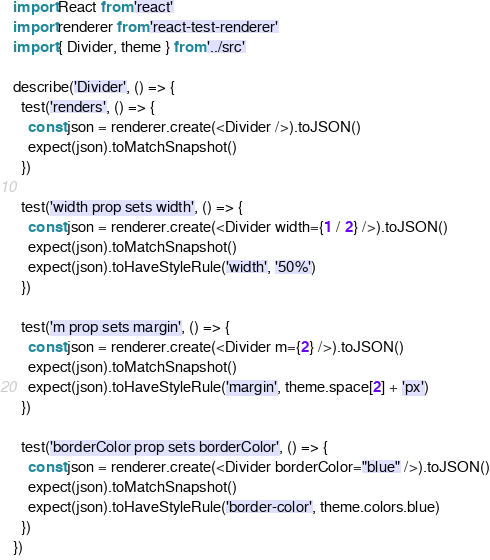Convert code to text. <code><loc_0><loc_0><loc_500><loc_500><_JavaScript_>import React from 'react'
import renderer from 'react-test-renderer'
import { Divider, theme } from '../src'

describe('Divider', () => {
  test('renders', () => {
    const json = renderer.create(<Divider />).toJSON()
    expect(json).toMatchSnapshot()
  })

  test('width prop sets width', () => {
    const json = renderer.create(<Divider width={1 / 2} />).toJSON()
    expect(json).toMatchSnapshot()
    expect(json).toHaveStyleRule('width', '50%')
  })

  test('m prop sets margin', () => {
    const json = renderer.create(<Divider m={2} />).toJSON()
    expect(json).toMatchSnapshot()
    expect(json).toHaveStyleRule('margin', theme.space[2] + 'px')
  })

  test('borderColor prop sets borderColor', () => {
    const json = renderer.create(<Divider borderColor="blue" />).toJSON()
    expect(json).toMatchSnapshot()
    expect(json).toHaveStyleRule('border-color', theme.colors.blue)
  })
})
</code> 